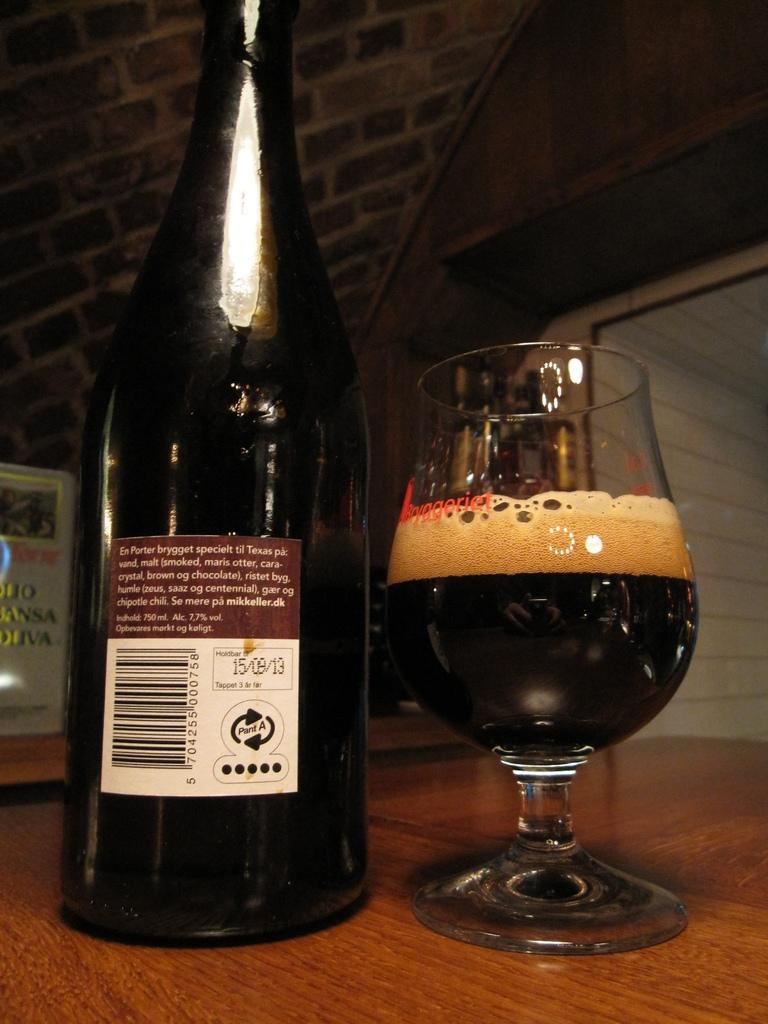What type of table is in the image? There is a wooden table in the image. What is on the table? There is a bottle and a glass with liquid on the table. What is behind the glass? There is an object behind the glass. What can be seen in the background of the image? There is a wall visible in the image. Is there any blood visible on the table in the image? No, there is no blood visible on the table in the image. Can you make a wish by looking at the object behind the glass? The image does not suggest that making a wish is possible by looking at the object behind the glass. 